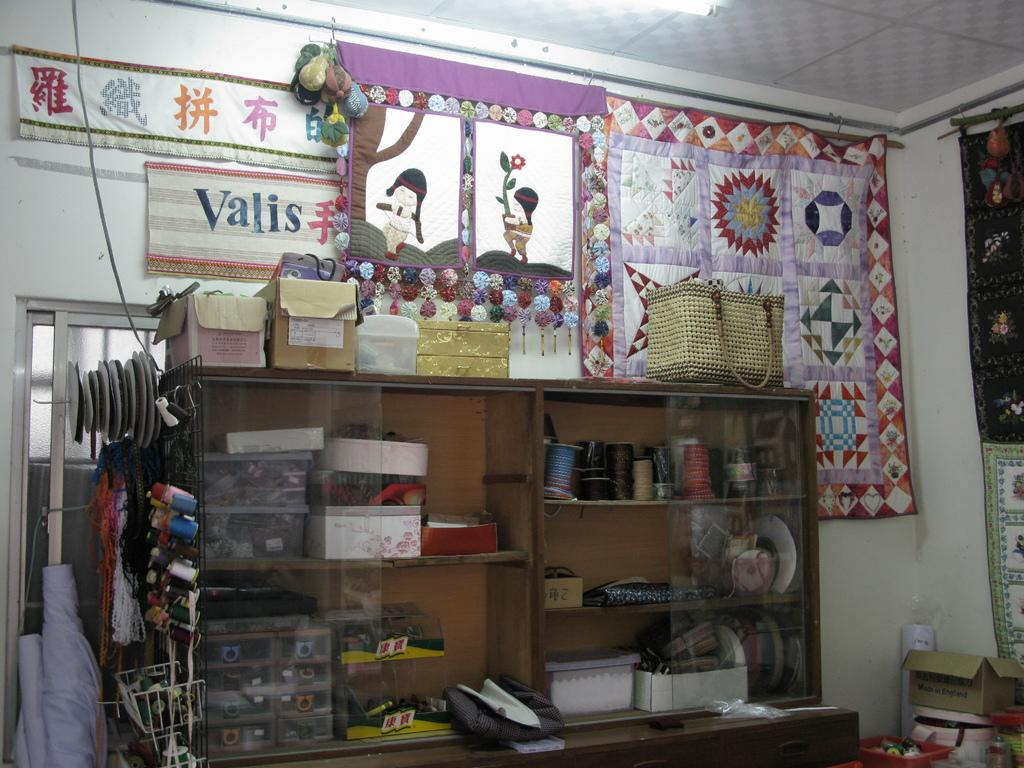<image>
Relay a brief, clear account of the picture shown. A sign that says Valis is over a shelving unit. 